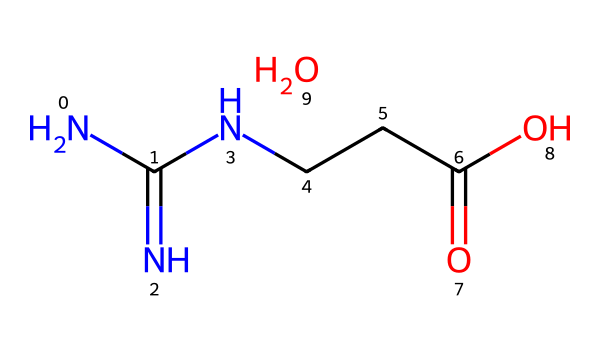What is the molecular formula of creatine monohydrate? The SMILES representation reveals two major parts: NC(=N)NCCC(=O)O represents the creatine and O represents the water in monohydrate, indicating the presence of one water molecule. Breaking it down: C (carbon), H (hydrogen), N (nitrogen), and O (oxygen) atoms can be counted to derive the total molecular formula.
Answer: C4H9N3O2 How many nitrogen atoms are present in creatine monohydrate? From the structure, there are 3 nitrogen atoms (noted by the "N" symbols in the SMILES) in the creatine part, adding to the molecular count.
Answer: 3 What functional groups are present in creatine monohydrate? The molecule has an amine group (–NH2) represented by NC groups and a carboxylic acid group (–COOH) represented by CCC(=O)O, identifying key functional groups.
Answer: amine and carboxylic acid How many carbon atoms are in creatine monohydrate? By inspecting the SMILES for C symbols, there are 4 carbon atoms in total, including those in the water molecule.
Answer: 4 What type of solvent can creatine monohydrate be dissolved in? Given the presence of hydroxyl groups and its polar nature, creatine monohydrate is likely to dissolve well in polar solvents like water. This aligns with typical solubility rules for polar compounds.
Answer: water What is the significance of the carboxylic acid group in creatine monohydrate? The carboxylic acid group contributes to the solubility of creatine in water and plays a role in the regulation of physiological activity in the body, impacting absorption and bioavailability.
Answer: solubility 